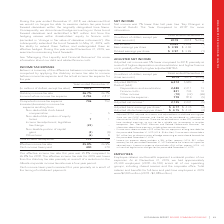According to Rogers Communications's financial document, What was the effective tax rate in 2019? According to the financial document, 25.8%. The relevant text states: "Effective income tax rate 25.8% 26.9% Cash income taxes paid 400 370..." Also, What was the effective tax rate in 2018? According to the financial document, 26.9%. The relevant text states: "Effective income tax rate 25.8% 26.9% Cash income taxes paid 400 370..." Also, What was the reason was decrease in effective tax rate from 2019 to 2018? result of a reduction to the Alberta corporate income tax rate over a four-year period. The document states: "lower than the statutory tax rate primarily as a result of a reduction to the Alberta corporate income tax rate over a four-year period...." Also, can you calculate: What was the increase / (decrease) in Income before income tax expense from 2019 to 2018? Based on the calculation: 2,755 - 2,817, the result is -62 (in millions). This is based on the information: "rate 26.7% 26.7% Income before income tax expense 2,755 2,817 6.7% 26.7% Income before income tax expense 2,755 2,817..." The key data points involved are: 2,755, 2,817. Also, can you calculate: What was the average Computed income tax expense? To answer this question, I need to perform calculations using the financial data. The calculation is: (736 + 752) / 2, which equals 744 (in millions). This is based on the information: "Computed income tax expense 736 752 Increase (decrease) in income tax expense resulting from: Non-deductible stock-based compensati Computed income tax expense 736 752 Increase (decrease) in income ta..." The key data points involved are: 736, 752. Also, can you calculate: What was the percentage increase / (decrease) in Total income tax expense from 2018 to 2019? To answer this question, I need to perform calculations using the financial data. The calculation is: 712 / 758 - 1, which equals -6.07 (percentage). This is based on the information: "Total income tax expense 712 758 Total income tax expense 712 758..." The key data points involved are: 712, 758. 